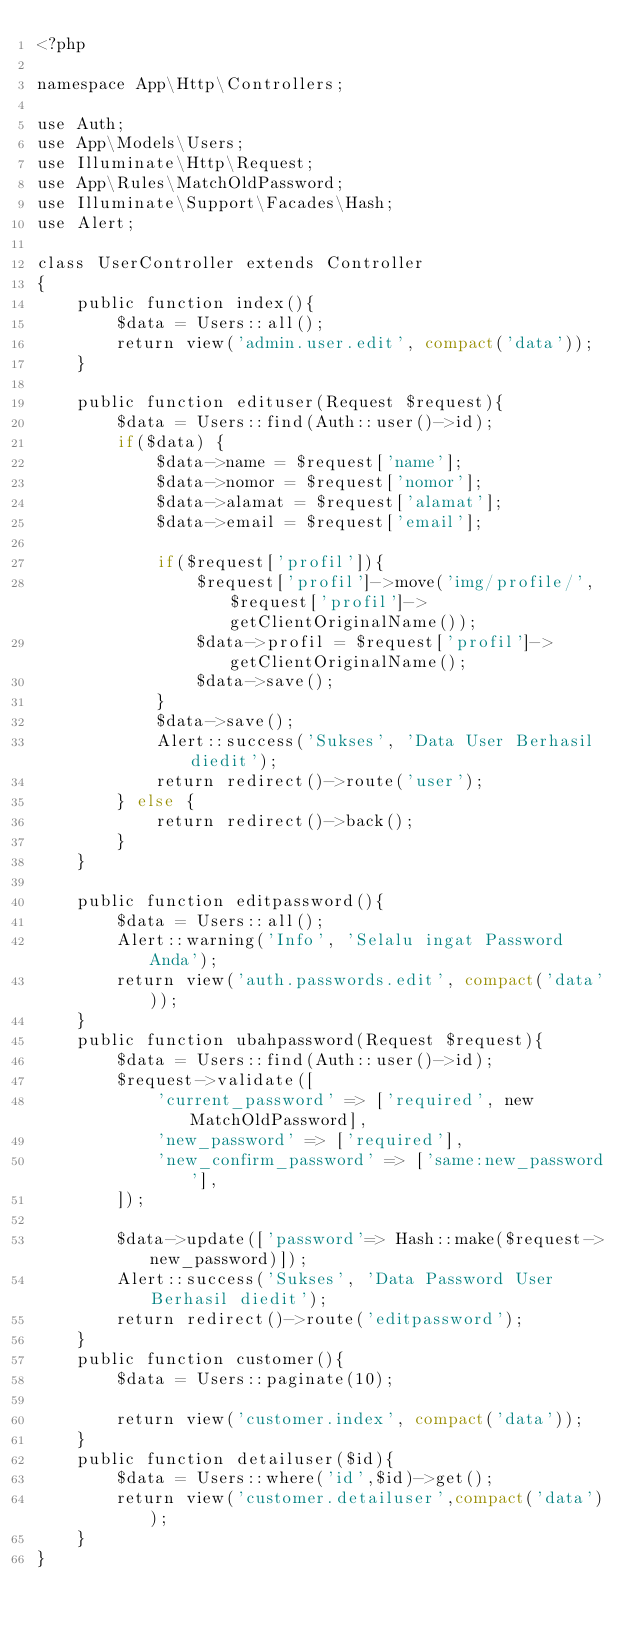<code> <loc_0><loc_0><loc_500><loc_500><_PHP_><?php

namespace App\Http\Controllers;

use Auth;
use App\Models\Users;
use Illuminate\Http\Request;
use App\Rules\MatchOldPassword;
use Illuminate\Support\Facades\Hash;
use Alert;

class UserController extends Controller
{
    public function index(){
        $data = Users::all();
        return view('admin.user.edit', compact('data'));
    }

    public function edituser(Request $request){
        $data = Users::find(Auth::user()->id);
        if($data) { 
            $data->name = $request['name'];
            $data->nomor = $request['nomor'];
            $data->alamat = $request['alamat'];
            $data->email = $request['email'];

            if($request['profil']){
                $request['profil']->move('img/profile/', $request['profil']->getClientOriginalName());
                $data->profil = $request['profil']->getClientOriginalName();
                $data->save();
            }
            $data->save();
            Alert::success('Sukses', 'Data User Berhasil diedit');
            return redirect()->route('user');
        } else {
            return redirect()->back();
        }
    }

    public function editpassword(){
        $data = Users::all();
        Alert::warning('Info', 'Selalu ingat Password Anda');
        return view('auth.passwords.edit', compact('data'));
    }
    public function ubahpassword(Request $request){
        $data = Users::find(Auth::user()->id);
        $request->validate([
            'current_password' => ['required', new MatchOldPassword],
            'new_password' => ['required'],
            'new_confirm_password' => ['same:new_password'],
        ]);
        
        $data->update(['password'=> Hash::make($request->new_password)]);
        Alert::success('Sukses', 'Data Password User Berhasil diedit');
        return redirect()->route('editpassword');
    }
    public function customer(){
        $data = Users::paginate(10);

        return view('customer.index', compact('data'));
    }
    public function detailuser($id){
        $data = Users::where('id',$id)->get();
        return view('customer.detailuser',compact('data'));
    }
}
</code> 